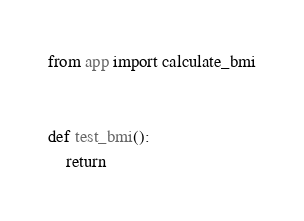<code> <loc_0><loc_0><loc_500><loc_500><_Python_>from app import calculate_bmi


def test_bmi():
    return</code> 